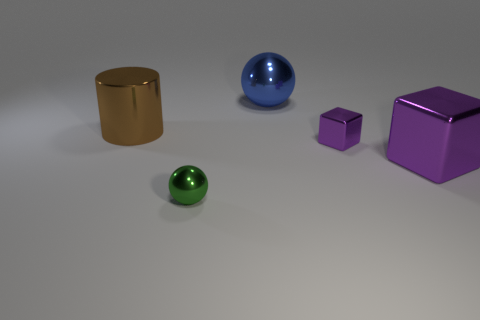Add 3 big red rubber balls. How many objects exist? 8 Subtract all spheres. How many objects are left? 3 Subtract 0 blue cylinders. How many objects are left? 5 Subtract all blue metal spheres. Subtract all big purple things. How many objects are left? 3 Add 1 large blue metallic spheres. How many large blue metallic spheres are left? 2 Add 5 tiny green metallic objects. How many tiny green metallic objects exist? 6 